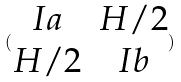Convert formula to latex. <formula><loc_0><loc_0><loc_500><loc_500>( \begin{matrix} I a & H / 2 \\ H / 2 & I b \end{matrix} )</formula> 